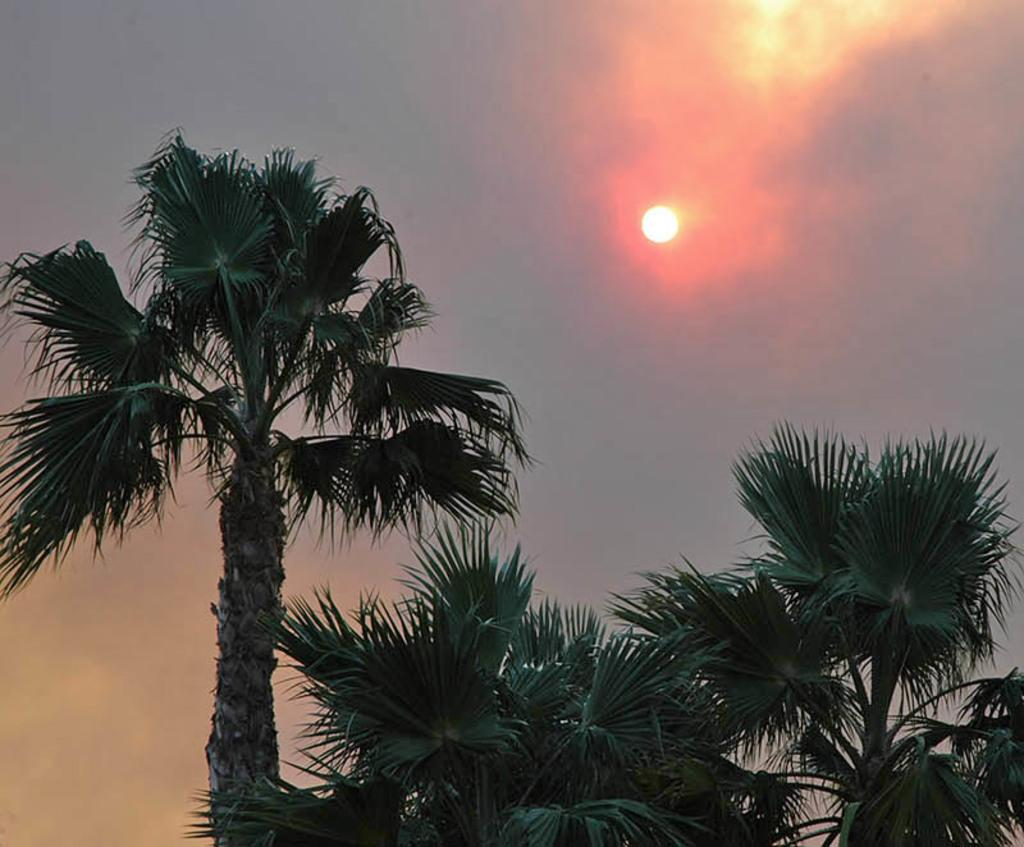What can be seen in abundance in the image? There are many trees in the image. What is visible in the sky in the image? The sun is visible in the sky. What is the expert's opinion on the cork in the image? There is no expert or cork present in the image, so it is not possible to answer that question. 